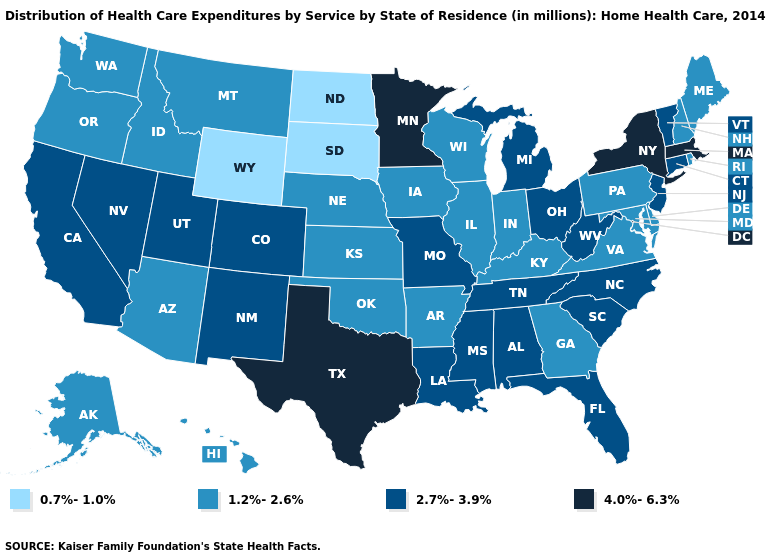Does South Dakota have the lowest value in the USA?
Write a very short answer. Yes. What is the value of Georgia?
Be succinct. 1.2%-2.6%. Is the legend a continuous bar?
Give a very brief answer. No. What is the value of Colorado?
Concise answer only. 2.7%-3.9%. Name the states that have a value in the range 4.0%-6.3%?
Keep it brief. Massachusetts, Minnesota, New York, Texas. Does the map have missing data?
Short answer required. No. Which states have the lowest value in the Northeast?
Be succinct. Maine, New Hampshire, Pennsylvania, Rhode Island. What is the highest value in the MidWest ?
Be succinct. 4.0%-6.3%. What is the value of Oklahoma?
Quick response, please. 1.2%-2.6%. What is the highest value in states that border Georgia?
Keep it brief. 2.7%-3.9%. What is the highest value in the USA?
Short answer required. 4.0%-6.3%. What is the lowest value in the Northeast?
Answer briefly. 1.2%-2.6%. Name the states that have a value in the range 0.7%-1.0%?
Concise answer only. North Dakota, South Dakota, Wyoming. What is the value of Connecticut?
Give a very brief answer. 2.7%-3.9%. What is the highest value in the West ?
Be succinct. 2.7%-3.9%. 